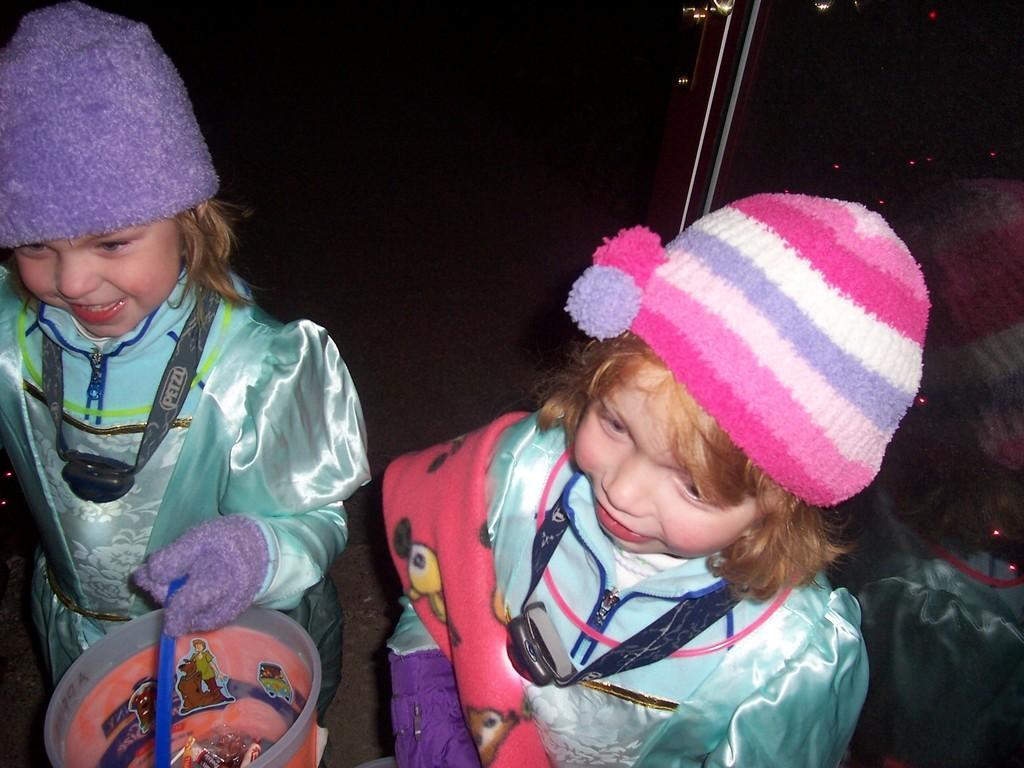How would you summarize this image in a sentence or two? In the center of the image two girls are standing and wearing hats. On the left side of the image a girl is holding an object. On the right side of the image mirror is there. At the bottom of the image ground is there. 